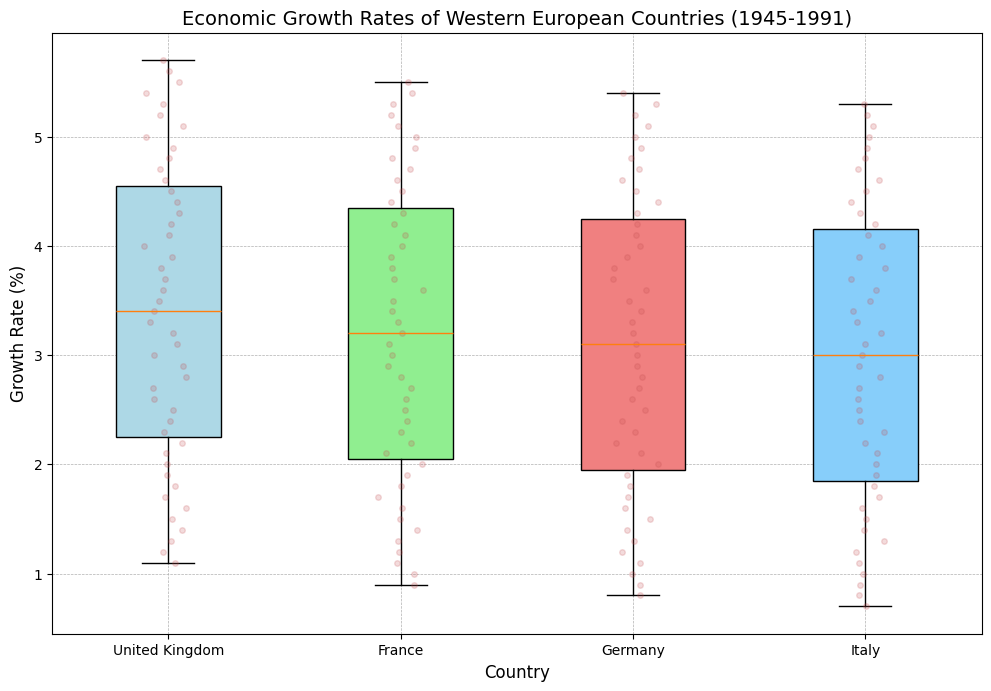Which country has the highest median economic growth rate? By examining the box plots, the country with the highest median is indicated by the position of the median line within the box.
Answer: United Kingdom What is the interquartile range (IQR) for Italy's economic growth rates? The IQR is calculated by finding the difference between the first quartile (Q1) and third quartile (Q3) of the box plot for Italy.
Answer: Approximately 2.5% Which country shows the most consistent growth rates over the years? Consistency can be inferred from the spread of the box plot—narrower boxes indicate more consistency.
Answer: Germany How does the spread of growth rates in France compare to that in the United Kingdom? To compare spreads, look at the range of each box plot and the distance between the whiskers. France's range (spread) is slightly narrower than that of the United Kingdom, indicating less variability.
Answer: France has a narrower spread What is the approximate average growth rate of the United Kingdom? The average growth rate can be visually estimated as being between the lowest and highest points around the center (median) of the box plot. The United Kingdom's median is around 3.35% and spans from approximately 1.1% to 5.7%.
Answer: Approximately 3.4% Which country displays the greatest range of economic growth rates? The range is indicated by the distance between the minimum and maximum whiskers. By comparing all countries, identify the one with the largest spread.
Answer: United Kingdom Does any country show an outlier in its economic growth rates? Outliers are often represented as dots outside the whiskers of a box plot. Check each country for any such dots.
Answer: None Between France and Italy, which country had a higher median growth rate? The median is shown by the line inside the box. Compare the median lines for France and Italy to determine which is higher.
Answer: France What can you infer about the economic growth pattern in Western European countries from this box plot? This requires a synthesis of observations from the box plot, such as the consistency and variability of growth rates across the countries shown.
Answer: Generally steady growth with some variability; the United Kingdom has the widest range while Germany is the most consistent 